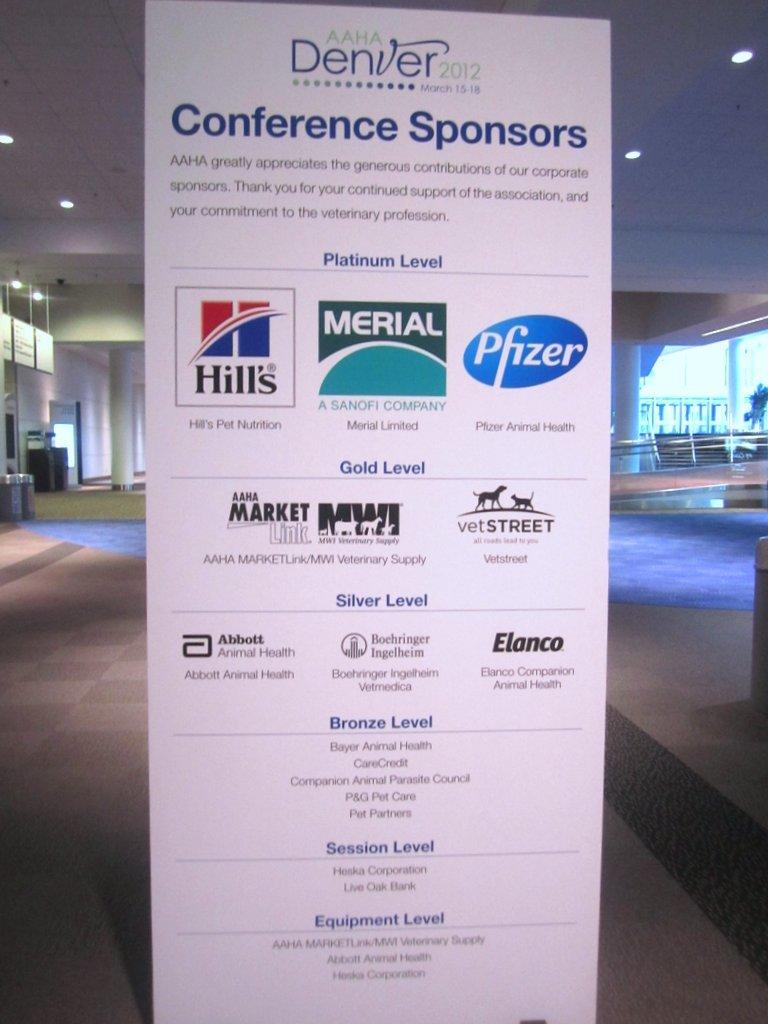What is the middle sponsor?
Provide a succinct answer. Merial. What year is this conference taking place?
Your answer should be compact. 2012. 